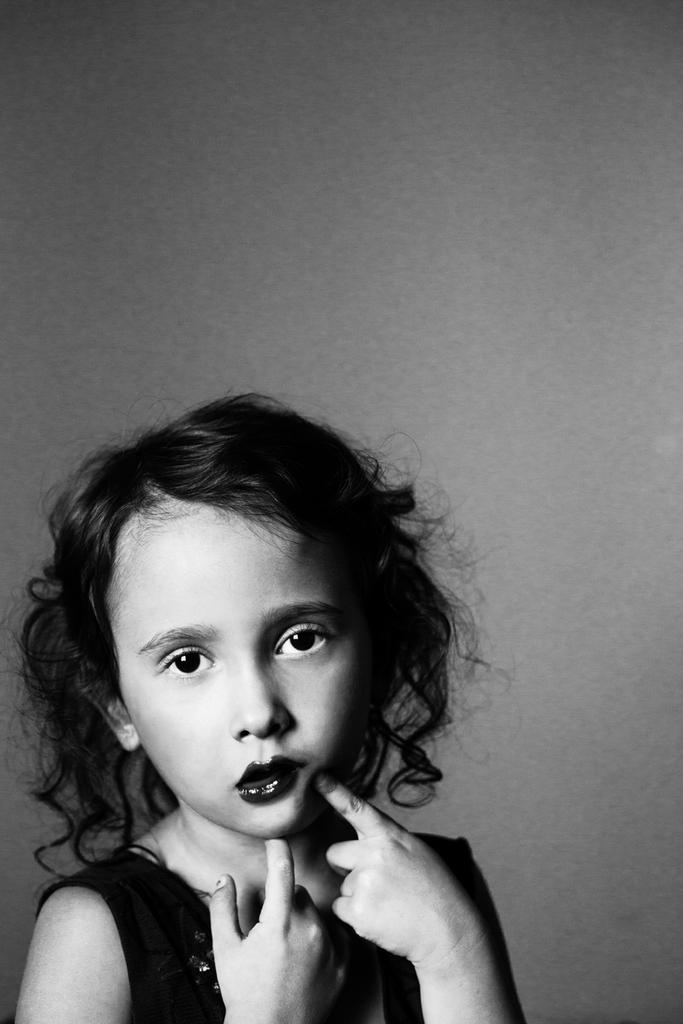Who is present in the image? There is a girl in the image. What can be seen in the background of the image? There is a wall in the image. How far is the swing from the girl in the image? There is no swing present in the image, so it is not possible to determine the distance between the girl and a swing. 